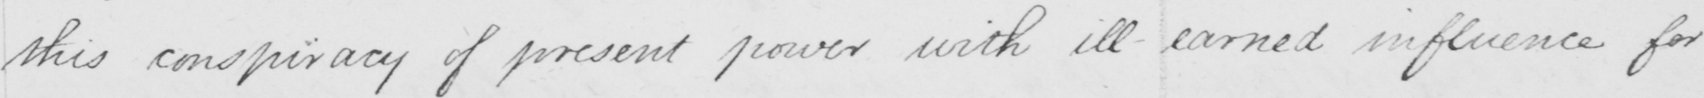Please transcribe the handwritten text in this image. this conspiracy of present power with ill-earned influence for 